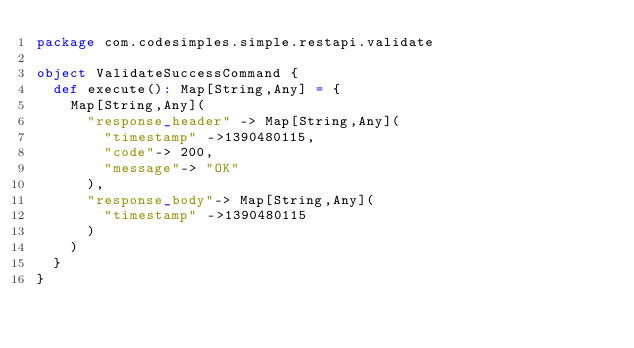Convert code to text. <code><loc_0><loc_0><loc_500><loc_500><_Scala_>package com.codesimples.simple.restapi.validate

object ValidateSuccessCommand {
  def execute(): Map[String,Any] = {
    Map[String,Any](
      "response_header" -> Map[String,Any](
        "timestamp" ->1390480115,
        "code"-> 200,
        "message"-> "OK"
      ),
      "response_body"-> Map[String,Any](
        "timestamp" ->1390480115
      )
    )
  }
}
</code> 